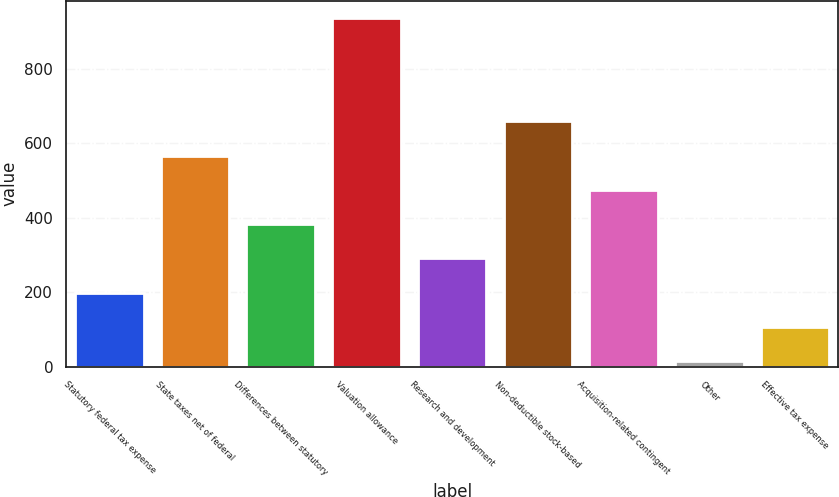Convert chart to OTSL. <chart><loc_0><loc_0><loc_500><loc_500><bar_chart><fcel>Statutory federal tax expense<fcel>State taxes net of federal<fcel>Differences between statutory<fcel>Valuation allowance<fcel>Research and development<fcel>Non-deductible stock-based<fcel>Acquisition-related contingent<fcel>Other<fcel>Effective tax expense<nl><fcel>198.74<fcel>567.62<fcel>383.18<fcel>936.5<fcel>290.96<fcel>659.84<fcel>475.4<fcel>14.3<fcel>106.52<nl></chart> 